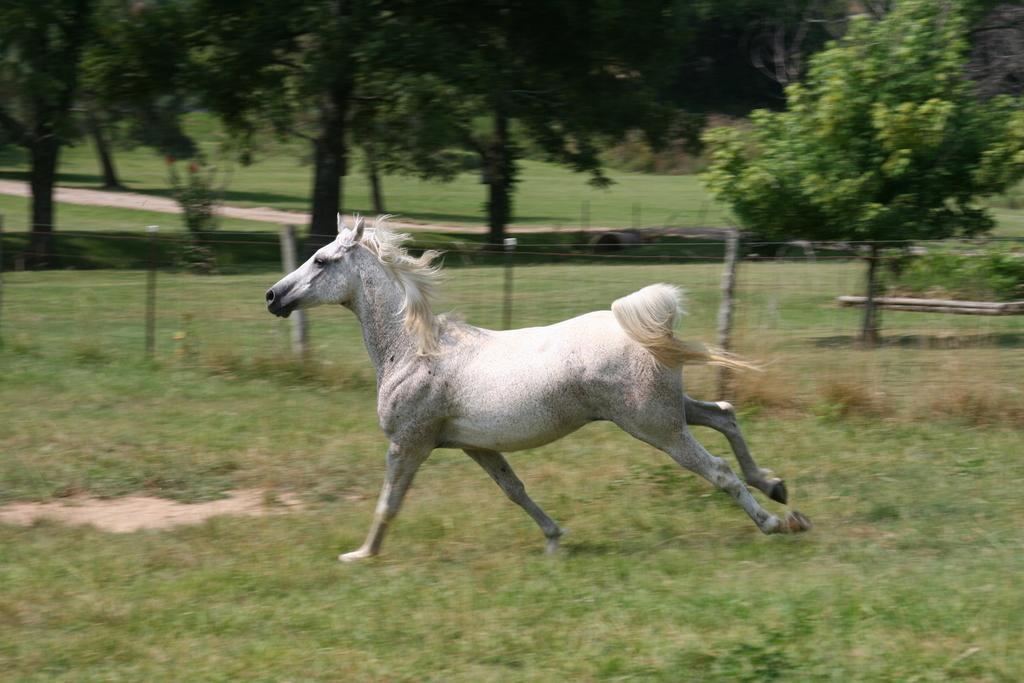Can you describe this image briefly? In the foreground of the picture I can see a white horse running on the green grass. I can see the stone pole metal wire fencing. In the background, I can see the trees. 